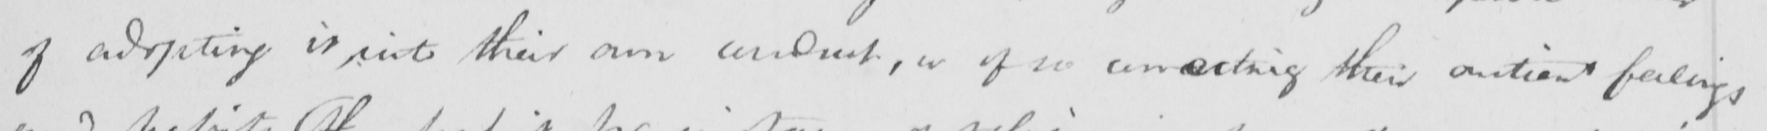What does this handwritten line say? of adopting it into their own conduct , or of so unseating their antient feelings 